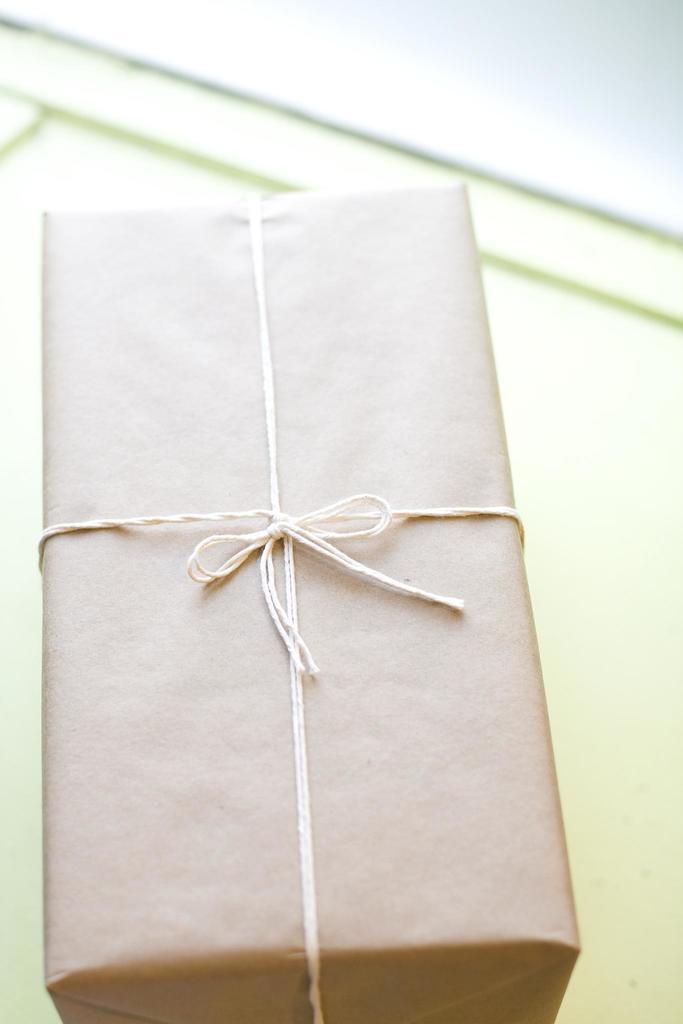Can you describe this image briefly? In the image we can see there is a box kept on the table and it is tied with white colour thread. 